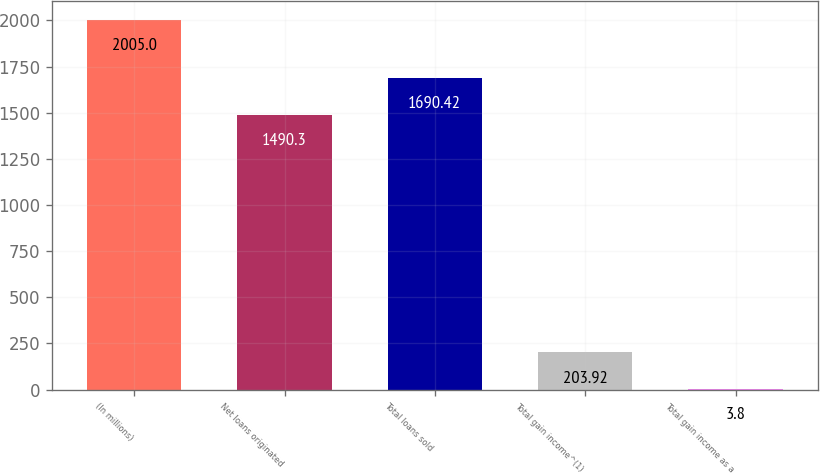<chart> <loc_0><loc_0><loc_500><loc_500><bar_chart><fcel>(In millions)<fcel>Net loans originated<fcel>Total loans sold<fcel>Total gain income^(1)<fcel>Total gain income as a<nl><fcel>2005<fcel>1490.3<fcel>1690.42<fcel>203.92<fcel>3.8<nl></chart> 